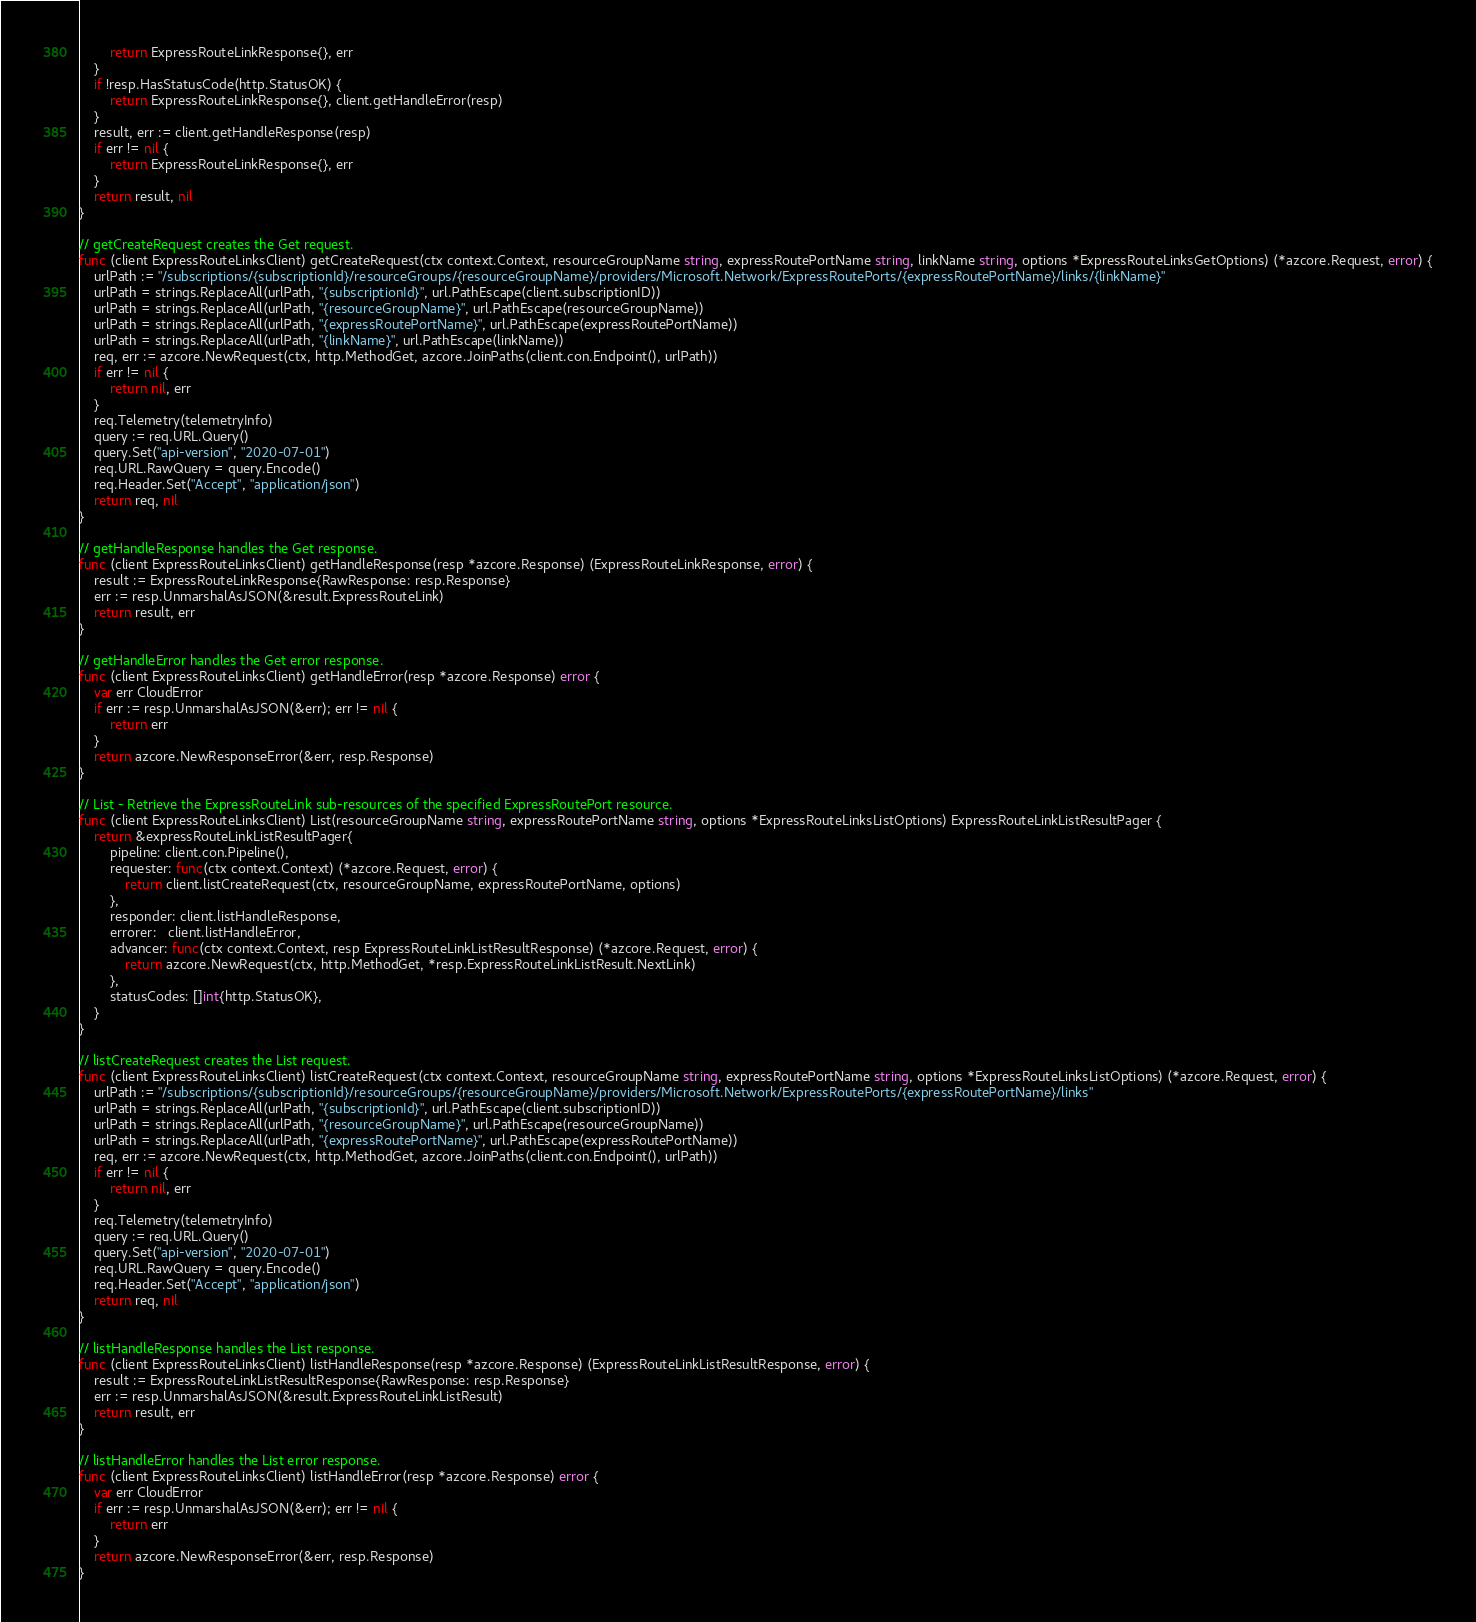<code> <loc_0><loc_0><loc_500><loc_500><_Go_>		return ExpressRouteLinkResponse{}, err
	}
	if !resp.HasStatusCode(http.StatusOK) {
		return ExpressRouteLinkResponse{}, client.getHandleError(resp)
	}
	result, err := client.getHandleResponse(resp)
	if err != nil {
		return ExpressRouteLinkResponse{}, err
	}
	return result, nil
}

// getCreateRequest creates the Get request.
func (client ExpressRouteLinksClient) getCreateRequest(ctx context.Context, resourceGroupName string, expressRoutePortName string, linkName string, options *ExpressRouteLinksGetOptions) (*azcore.Request, error) {
	urlPath := "/subscriptions/{subscriptionId}/resourceGroups/{resourceGroupName}/providers/Microsoft.Network/ExpressRoutePorts/{expressRoutePortName}/links/{linkName}"
	urlPath = strings.ReplaceAll(urlPath, "{subscriptionId}", url.PathEscape(client.subscriptionID))
	urlPath = strings.ReplaceAll(urlPath, "{resourceGroupName}", url.PathEscape(resourceGroupName))
	urlPath = strings.ReplaceAll(urlPath, "{expressRoutePortName}", url.PathEscape(expressRoutePortName))
	urlPath = strings.ReplaceAll(urlPath, "{linkName}", url.PathEscape(linkName))
	req, err := azcore.NewRequest(ctx, http.MethodGet, azcore.JoinPaths(client.con.Endpoint(), urlPath))
	if err != nil {
		return nil, err
	}
	req.Telemetry(telemetryInfo)
	query := req.URL.Query()
	query.Set("api-version", "2020-07-01")
	req.URL.RawQuery = query.Encode()
	req.Header.Set("Accept", "application/json")
	return req, nil
}

// getHandleResponse handles the Get response.
func (client ExpressRouteLinksClient) getHandleResponse(resp *azcore.Response) (ExpressRouteLinkResponse, error) {
	result := ExpressRouteLinkResponse{RawResponse: resp.Response}
	err := resp.UnmarshalAsJSON(&result.ExpressRouteLink)
	return result, err
}

// getHandleError handles the Get error response.
func (client ExpressRouteLinksClient) getHandleError(resp *azcore.Response) error {
	var err CloudError
	if err := resp.UnmarshalAsJSON(&err); err != nil {
		return err
	}
	return azcore.NewResponseError(&err, resp.Response)
}

// List - Retrieve the ExpressRouteLink sub-resources of the specified ExpressRoutePort resource.
func (client ExpressRouteLinksClient) List(resourceGroupName string, expressRoutePortName string, options *ExpressRouteLinksListOptions) ExpressRouteLinkListResultPager {
	return &expressRouteLinkListResultPager{
		pipeline: client.con.Pipeline(),
		requester: func(ctx context.Context) (*azcore.Request, error) {
			return client.listCreateRequest(ctx, resourceGroupName, expressRoutePortName, options)
		},
		responder: client.listHandleResponse,
		errorer:   client.listHandleError,
		advancer: func(ctx context.Context, resp ExpressRouteLinkListResultResponse) (*azcore.Request, error) {
			return azcore.NewRequest(ctx, http.MethodGet, *resp.ExpressRouteLinkListResult.NextLink)
		},
		statusCodes: []int{http.StatusOK},
	}
}

// listCreateRequest creates the List request.
func (client ExpressRouteLinksClient) listCreateRequest(ctx context.Context, resourceGroupName string, expressRoutePortName string, options *ExpressRouteLinksListOptions) (*azcore.Request, error) {
	urlPath := "/subscriptions/{subscriptionId}/resourceGroups/{resourceGroupName}/providers/Microsoft.Network/ExpressRoutePorts/{expressRoutePortName}/links"
	urlPath = strings.ReplaceAll(urlPath, "{subscriptionId}", url.PathEscape(client.subscriptionID))
	urlPath = strings.ReplaceAll(urlPath, "{resourceGroupName}", url.PathEscape(resourceGroupName))
	urlPath = strings.ReplaceAll(urlPath, "{expressRoutePortName}", url.PathEscape(expressRoutePortName))
	req, err := azcore.NewRequest(ctx, http.MethodGet, azcore.JoinPaths(client.con.Endpoint(), urlPath))
	if err != nil {
		return nil, err
	}
	req.Telemetry(telemetryInfo)
	query := req.URL.Query()
	query.Set("api-version", "2020-07-01")
	req.URL.RawQuery = query.Encode()
	req.Header.Set("Accept", "application/json")
	return req, nil
}

// listHandleResponse handles the List response.
func (client ExpressRouteLinksClient) listHandleResponse(resp *azcore.Response) (ExpressRouteLinkListResultResponse, error) {
	result := ExpressRouteLinkListResultResponse{RawResponse: resp.Response}
	err := resp.UnmarshalAsJSON(&result.ExpressRouteLinkListResult)
	return result, err
}

// listHandleError handles the List error response.
func (client ExpressRouteLinksClient) listHandleError(resp *azcore.Response) error {
	var err CloudError
	if err := resp.UnmarshalAsJSON(&err); err != nil {
		return err
	}
	return azcore.NewResponseError(&err, resp.Response)
}
</code> 